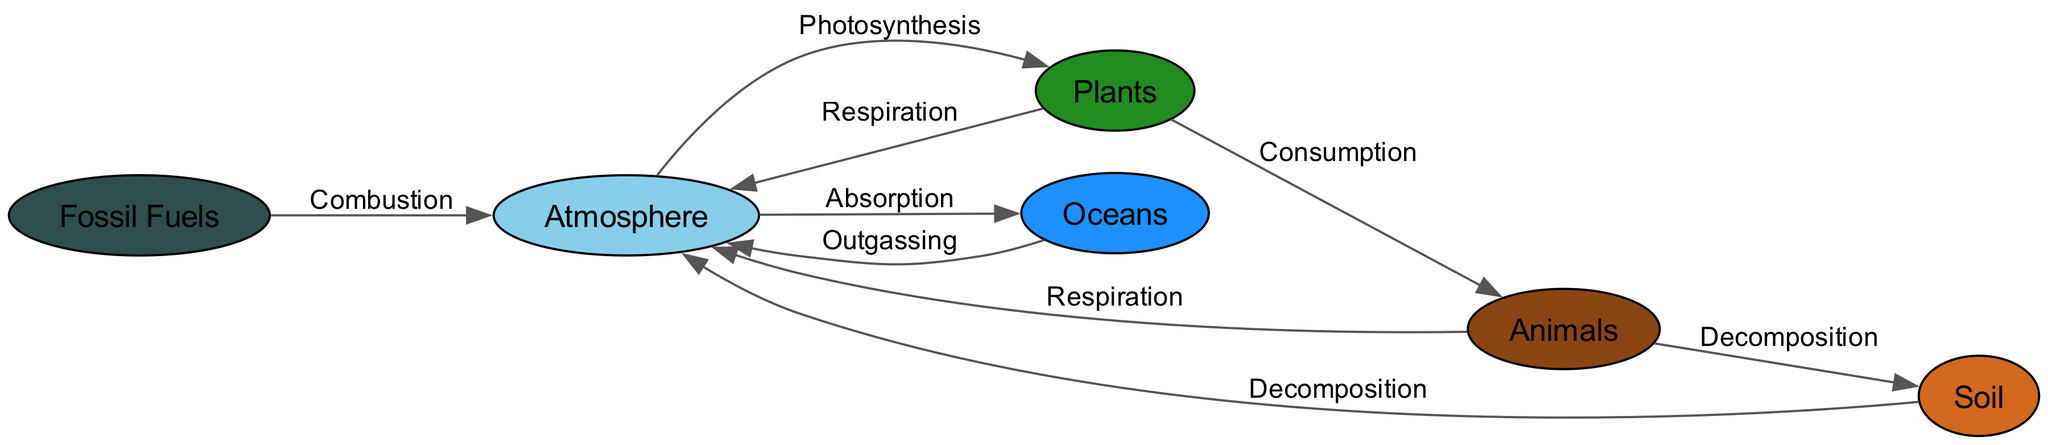What are the primary components of the carbon cycle? The diagram shows six primary components: Atmosphere, Plants, Animals, Soil, Oceans, and Fossil Fuels. These are the main nodes represented in the diagram.
Answer: Atmosphere, Plants, Animals, Soil, Oceans, Fossil Fuels How many edges are shown in the diagram? By counting the connections (edges) between the nodes, the diagram shows a total of 8 edges connecting the various components of the carbon cycle.
Answer: 8 What process moves carbon from the atmosphere to plants? The diagram indicates that carbon moves from the Atmosphere to Plants through the process of Photosynthesis, which is labeled on the edge connecting these two nodes.
Answer: Photosynthesis What transfers carbon from animals back to the atmosphere? The respiration process carried out by animals is indicated on the edge connecting Animals to Atmosphere. This shows that carbon is released back into the atmosphere via respiration after animals consume carbon from plants.
Answer: Respiration Which component absorbs carbon from the atmosphere? According to the diagram, the Oceans are designated as the component that absorbs carbon from the Atmosphere through the labeled process of Absorption, showing the flow of carbon into the oceans.
Answer: Oceans What process links soil back to the atmosphere? The process of Decomposition connects Soil back to the Atmosphere, as indicated on the edge depicting this relationship in the diagram, reflecting the carbon release that occurs during decomposition.
Answer: Decomposition Which node has a direct link to the combustion process? Fossil Fuels are directly connected to the Atmosphere through the process labeled as Combustion, illustrating how burning fossil fuels releases carbon into the atmosphere.
Answer: Fossil Fuels How many interactions do plants have with other nodes? The Plants node has three interactions: with the Atmosphere (Photosynthesis), with Animals (Consumption), and with the Atmosphere again (Respiration), making a total of three interactions in the diagram.
Answer: 3 What is the relationship between animals and soil? The diagram shows that the relationship between Animals and Soil is defined by the process of Decomposition, illustrating how animal matter contributes decomposed carbon to the soil.
Answer: Decomposition 